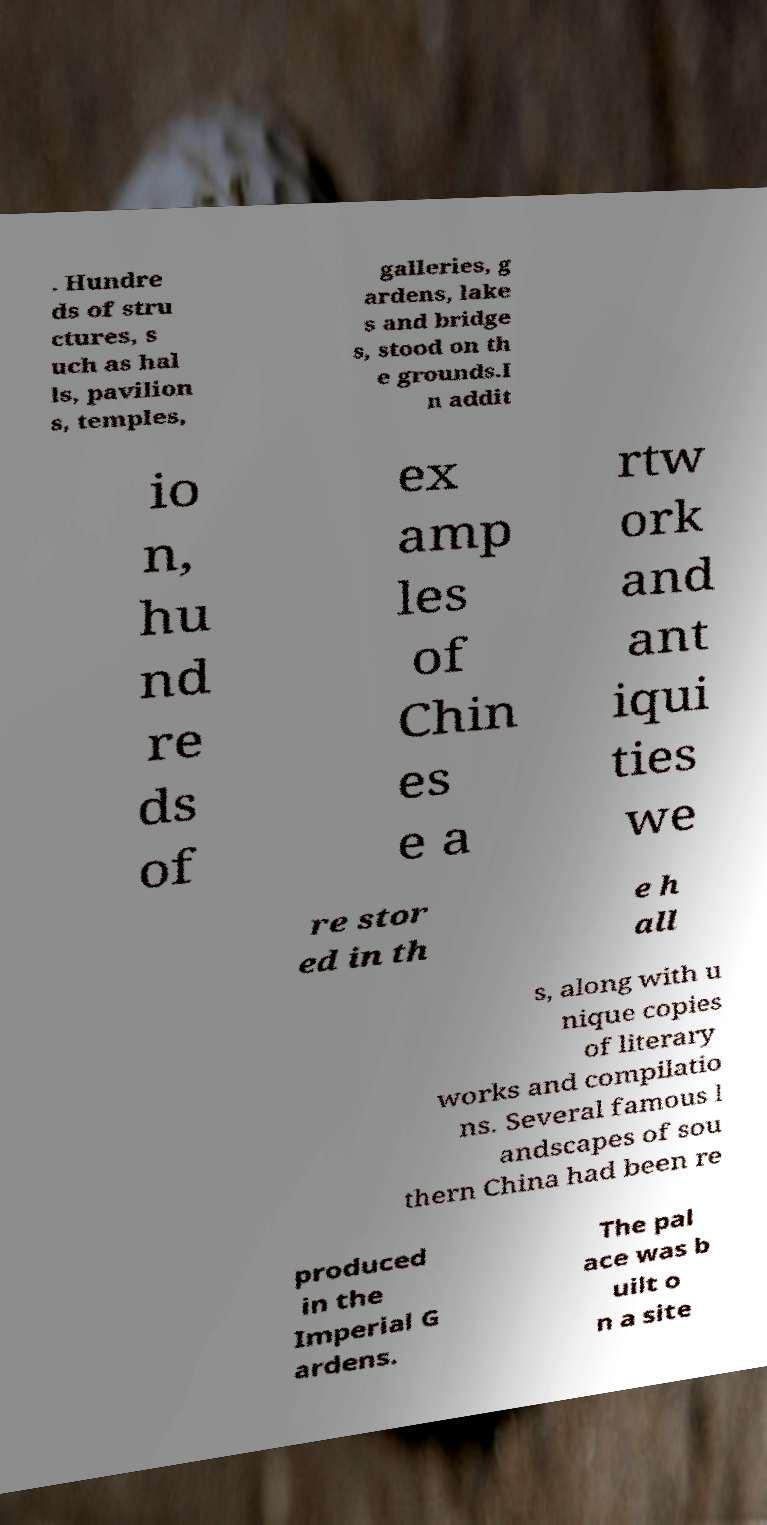Please read and relay the text visible in this image. What does it say? . Hundre ds of stru ctures, s uch as hal ls, pavilion s, temples, galleries, g ardens, lake s and bridge s, stood on th e grounds.I n addit io n, hu nd re ds of ex amp les of Chin es e a rtw ork and ant iqui ties we re stor ed in th e h all s, along with u nique copies of literary works and compilatio ns. Several famous l andscapes of sou thern China had been re produced in the Imperial G ardens. The pal ace was b uilt o n a site 